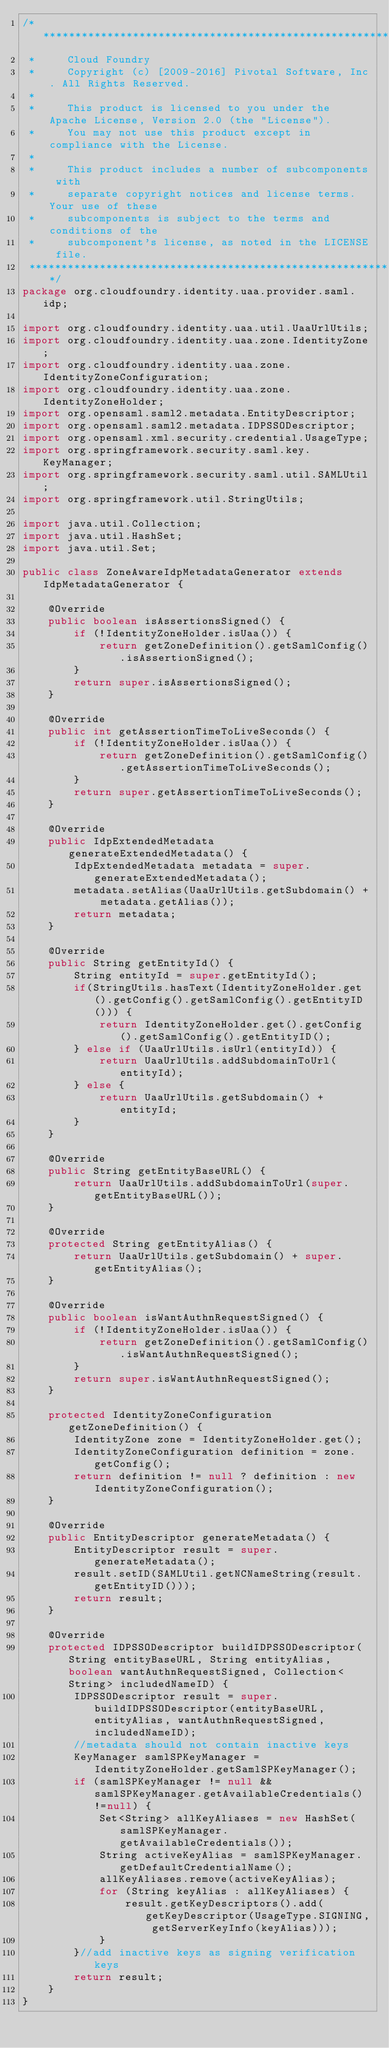<code> <loc_0><loc_0><loc_500><loc_500><_Java_>/*******************************************************************************
 *     Cloud Foundry
 *     Copyright (c) [2009-2016] Pivotal Software, Inc. All Rights Reserved.
 *
 *     This product is licensed to you under the Apache License, Version 2.0 (the "License").
 *     You may not use this product except in compliance with the License.
 *
 *     This product includes a number of subcomponents with
 *     separate copyright notices and license terms. Your use of these
 *     subcomponents is subject to the terms and conditions of the
 *     subcomponent's license, as noted in the LICENSE file.
 *******************************************************************************/
package org.cloudfoundry.identity.uaa.provider.saml.idp;

import org.cloudfoundry.identity.uaa.util.UaaUrlUtils;
import org.cloudfoundry.identity.uaa.zone.IdentityZone;
import org.cloudfoundry.identity.uaa.zone.IdentityZoneConfiguration;
import org.cloudfoundry.identity.uaa.zone.IdentityZoneHolder;
import org.opensaml.saml2.metadata.EntityDescriptor;
import org.opensaml.saml2.metadata.IDPSSODescriptor;
import org.opensaml.xml.security.credential.UsageType;
import org.springframework.security.saml.key.KeyManager;
import org.springframework.security.saml.util.SAMLUtil;
import org.springframework.util.StringUtils;

import java.util.Collection;
import java.util.HashSet;
import java.util.Set;

public class ZoneAwareIdpMetadataGenerator extends IdpMetadataGenerator {

    @Override
    public boolean isAssertionsSigned() {
        if (!IdentityZoneHolder.isUaa()) {
            return getZoneDefinition().getSamlConfig().isAssertionSigned();
        }
        return super.isAssertionsSigned();
    }

    @Override
    public int getAssertionTimeToLiveSeconds() {
        if (!IdentityZoneHolder.isUaa()) {
            return getZoneDefinition().getSamlConfig().getAssertionTimeToLiveSeconds();
        }
        return super.getAssertionTimeToLiveSeconds();
    }

    @Override
    public IdpExtendedMetadata generateExtendedMetadata() {
        IdpExtendedMetadata metadata = super.generateExtendedMetadata();
        metadata.setAlias(UaaUrlUtils.getSubdomain() + metadata.getAlias());
        return metadata;
    }

    @Override
    public String getEntityId() {
        String entityId = super.getEntityId();
        if(StringUtils.hasText(IdentityZoneHolder.get().getConfig().getSamlConfig().getEntityID())) {
            return IdentityZoneHolder.get().getConfig().getSamlConfig().getEntityID();
        } else if (UaaUrlUtils.isUrl(entityId)) {
            return UaaUrlUtils.addSubdomainToUrl(entityId);
        } else {
            return UaaUrlUtils.getSubdomain() + entityId;
        }
    }

    @Override
    public String getEntityBaseURL() {
        return UaaUrlUtils.addSubdomainToUrl(super.getEntityBaseURL());
    }

    @Override
    protected String getEntityAlias() {
        return UaaUrlUtils.getSubdomain() + super.getEntityAlias();
    }

    @Override
    public boolean isWantAuthnRequestSigned() {
        if (!IdentityZoneHolder.isUaa()) {
            return getZoneDefinition().getSamlConfig().isWantAuthnRequestSigned();
        }
        return super.isWantAuthnRequestSigned();
    }

    protected IdentityZoneConfiguration getZoneDefinition() {
        IdentityZone zone = IdentityZoneHolder.get();
        IdentityZoneConfiguration definition = zone.getConfig();
        return definition != null ? definition : new IdentityZoneConfiguration();
    }

    @Override
    public EntityDescriptor generateMetadata() {
        EntityDescriptor result = super.generateMetadata();
        result.setID(SAMLUtil.getNCNameString(result.getEntityID()));
        return result;
    }

    @Override
    protected IDPSSODescriptor buildIDPSSODescriptor(String entityBaseURL, String entityAlias, boolean wantAuthnRequestSigned, Collection<String> includedNameID) {
        IDPSSODescriptor result = super.buildIDPSSODescriptor(entityBaseURL, entityAlias, wantAuthnRequestSigned, includedNameID);
        //metadata should not contain inactive keys
        KeyManager samlSPKeyManager = IdentityZoneHolder.getSamlSPKeyManager();
        if (samlSPKeyManager != null && samlSPKeyManager.getAvailableCredentials()!=null) {
            Set<String> allKeyAliases = new HashSet(samlSPKeyManager.getAvailableCredentials());
            String activeKeyAlias = samlSPKeyManager.getDefaultCredentialName();
            allKeyAliases.remove(activeKeyAlias);
            for (String keyAlias : allKeyAliases) {
                result.getKeyDescriptors().add(getKeyDescriptor(UsageType.SIGNING, getServerKeyInfo(keyAlias)));
            }
        }//add inactive keys as signing verification keys
        return result;
    }
}
</code> 